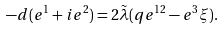<formula> <loc_0><loc_0><loc_500><loc_500>- d ( e ^ { 1 } + i e ^ { 2 } ) = 2 \tilde { \lambda } ( q e ^ { 1 2 } - e ^ { 3 } \xi ) .</formula> 